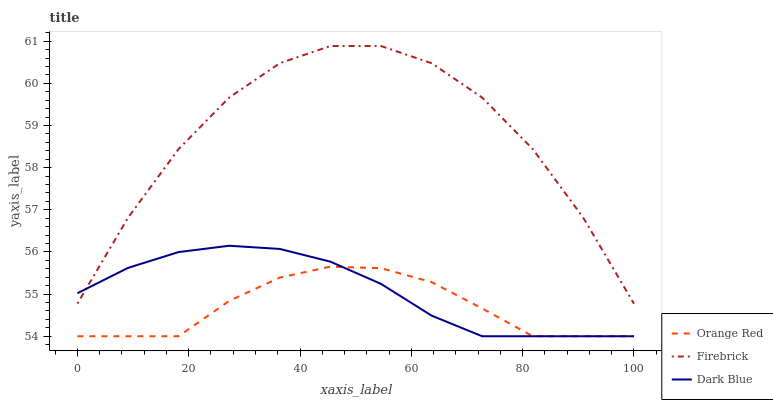Does Orange Red have the minimum area under the curve?
Answer yes or no. Yes. Does Firebrick have the maximum area under the curve?
Answer yes or no. Yes. Does Firebrick have the minimum area under the curve?
Answer yes or no. No. Does Orange Red have the maximum area under the curve?
Answer yes or no. No. Is Dark Blue the smoothest?
Answer yes or no. Yes. Is Firebrick the roughest?
Answer yes or no. Yes. Is Orange Red the smoothest?
Answer yes or no. No. Is Orange Red the roughest?
Answer yes or no. No. Does Dark Blue have the lowest value?
Answer yes or no. Yes. Does Firebrick have the lowest value?
Answer yes or no. No. Does Firebrick have the highest value?
Answer yes or no. Yes. Does Orange Red have the highest value?
Answer yes or no. No. Is Orange Red less than Firebrick?
Answer yes or no. Yes. Is Firebrick greater than Orange Red?
Answer yes or no. Yes. Does Dark Blue intersect Orange Red?
Answer yes or no. Yes. Is Dark Blue less than Orange Red?
Answer yes or no. No. Is Dark Blue greater than Orange Red?
Answer yes or no. No. Does Orange Red intersect Firebrick?
Answer yes or no. No. 